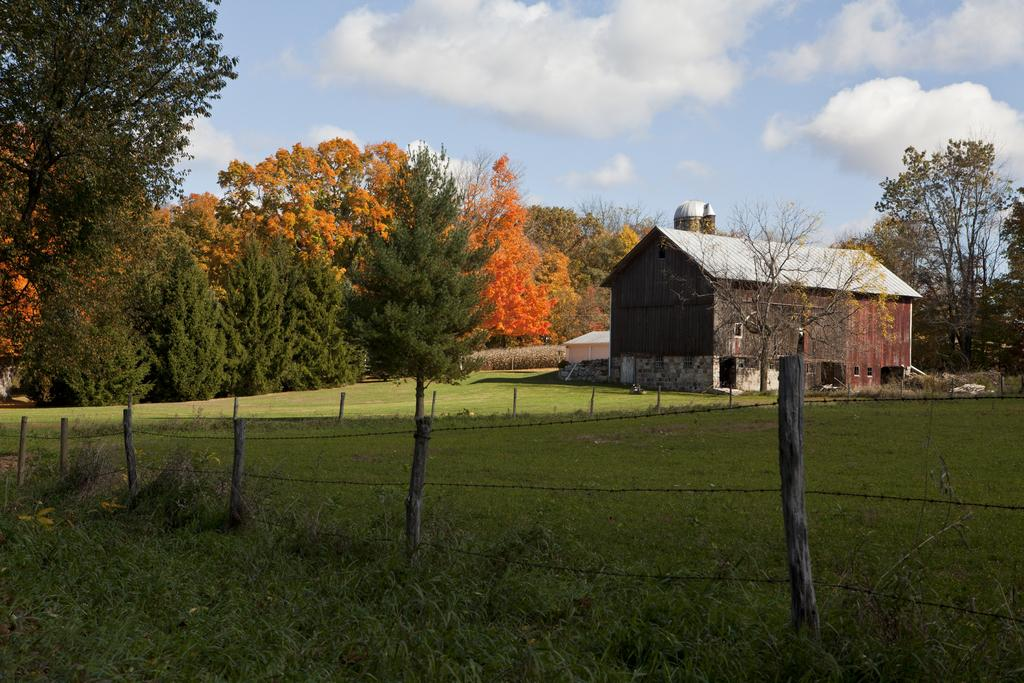What type of vegetation is present in the image? There is grass in the image. What type of structure can be seen in the image? There is a house in the image. What is the purpose of the fence in the image? The fence in the image serves as a boundary or barrier. What can be seen in the background of the image? There are trees in the background of the image. What is visible at the top of the image? The sky is visible at the top of the image. What can be observed in the sky? There are clouds in the sky. What type of popcorn is being served in the kettle in the image? There is no popcorn or kettle present in the image. How can we ensure that the area remains quiet in the image? The image does not depict any sound or noise levels, so it is not possible to determine how to maintain quietness from the image alone. 